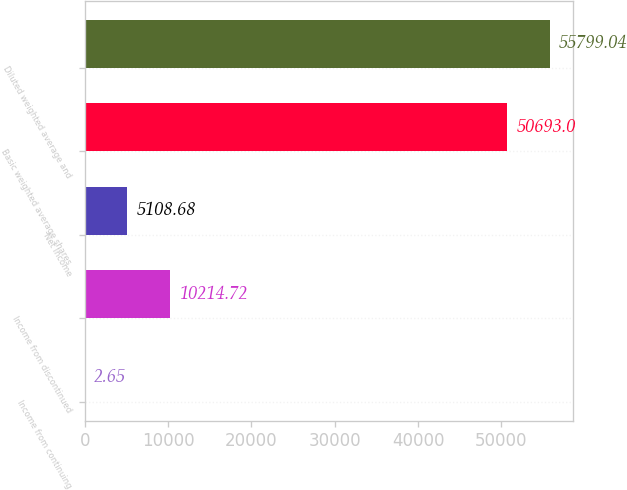Convert chart. <chart><loc_0><loc_0><loc_500><loc_500><bar_chart><fcel>Income from continuing<fcel>Income from discontinued<fcel>Net Income<fcel>Basic weighted average shares<fcel>Diluted weighted average and<nl><fcel>2.65<fcel>10214.7<fcel>5108.68<fcel>50693<fcel>55799<nl></chart> 